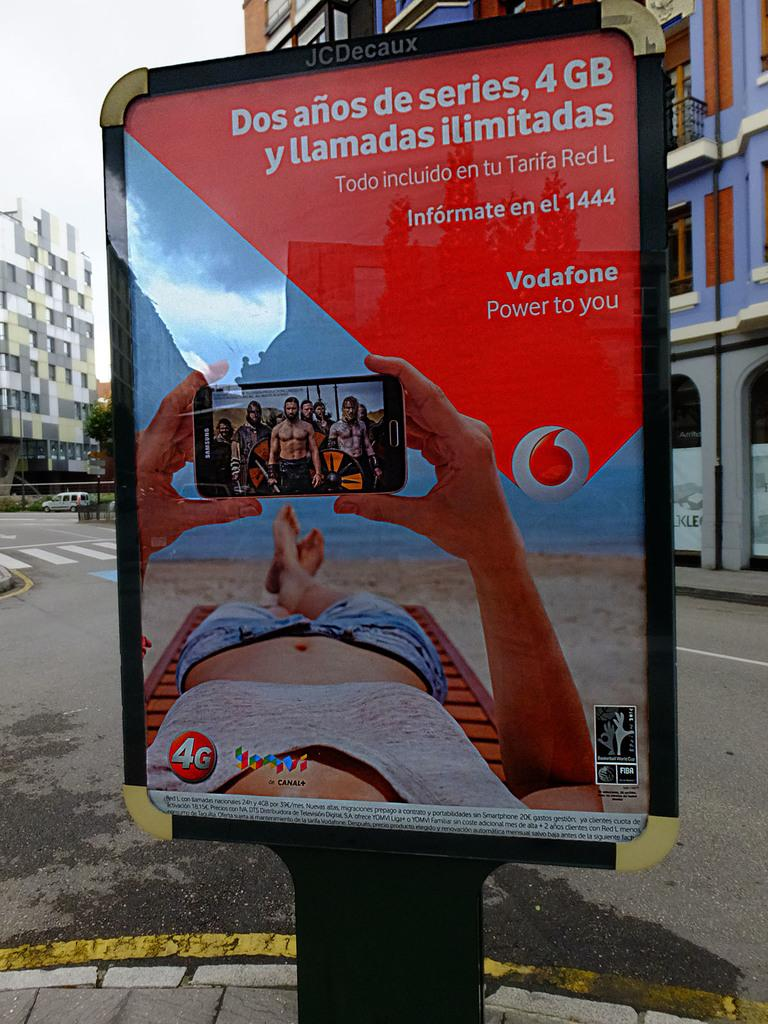<image>
Present a compact description of the photo's key features. An advertisement on cell phone data from Vodaphone is displayed on a sign. 